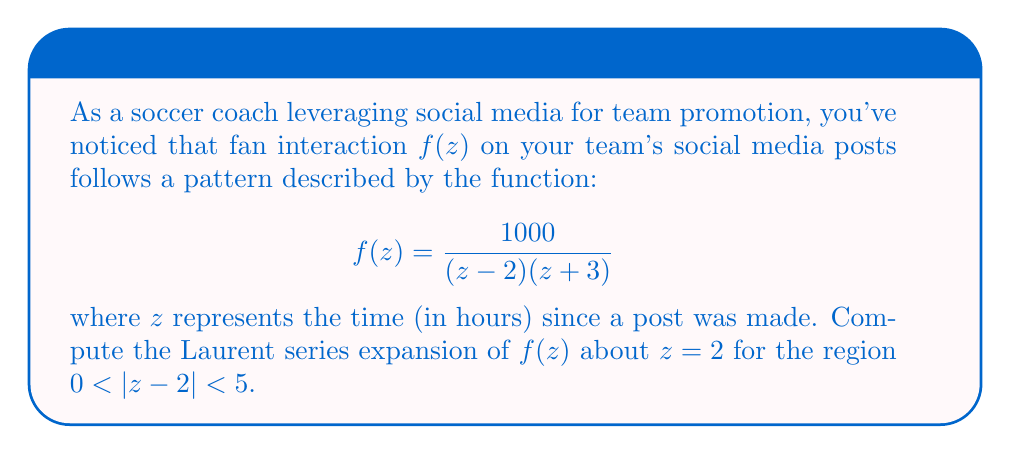Help me with this question. To find the Laurent series expansion of $f(z)$ about $z=2$, we'll follow these steps:

1) First, we need to rewrite the function in terms of $(z-2)$:
   $$f(z) = \frac{1000}{(z-2)(z+3)} = \frac{1000}{(z-2)((z-2)+5)}$$

2) Now, we can factor out $(z-2)$ from the denominator:
   $$f(z) = \frac{1000}{(z-2)(5+(z-2))} = \frac{1000}{5(z-2)(1+\frac{z-2}{5})}$$

3) Let $w = \frac{z-2}{5}$. Then our function becomes:
   $$f(z) = \frac{200}{5w(1+w)} = \frac{40}{w(1+w)}$$

4) We can use the geometric series formula $\frac{1}{1+w} = 1 - w + w^2 - w^3 + ...$, valid for $|w| < 1$:
   $$f(z) = \frac{40}{w}(1 - w + w^2 - w^3 + ...)$$

5) Substituting back $w = \frac{z-2}{5}$:
   $$f(z) = \frac{200}{z-2} - 40 + \frac{40(z-2)}{5} - \frac{40(z-2)^2}{25} + \frac{40(z-2)^3}{125} - ...$$

6) This series is valid when $|\frac{z-2}{5}| < 1$, or $|z-2| < 5$, which matches our given region.

Therefore, the Laurent series expansion of $f(z)$ about $z=2$ for $0 < |z-2| < 5$ is:

$$f(z) = \frac{200}{z-2} - 40 + 8(z-2) - \frac{8}{5}(z-2)^2 + \frac{32}{125}(z-2)^3 - ...$$
Answer: $\frac{200}{z-2} - 40 + 8(z-2) - \frac{8}{5}(z-2)^2 + \frac{32}{125}(z-2)^3 - ...$, valid for $0 < |z-2| < 5$ 